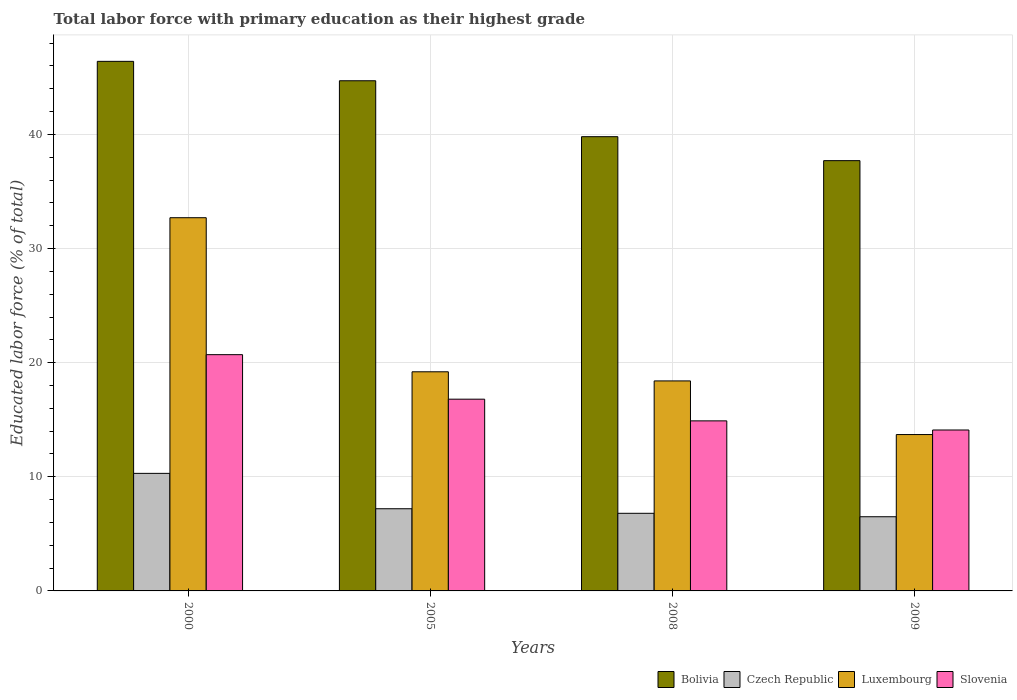How many different coloured bars are there?
Your response must be concise. 4. How many groups of bars are there?
Offer a very short reply. 4. Are the number of bars on each tick of the X-axis equal?
Your answer should be very brief. Yes. How many bars are there on the 3rd tick from the right?
Your answer should be very brief. 4. In how many cases, is the number of bars for a given year not equal to the number of legend labels?
Your answer should be compact. 0. What is the percentage of total labor force with primary education in Luxembourg in 2008?
Your answer should be very brief. 18.4. Across all years, what is the maximum percentage of total labor force with primary education in Bolivia?
Give a very brief answer. 46.4. In which year was the percentage of total labor force with primary education in Bolivia minimum?
Your response must be concise. 2009. What is the total percentage of total labor force with primary education in Luxembourg in the graph?
Provide a succinct answer. 84. What is the difference between the percentage of total labor force with primary education in Slovenia in 2000 and the percentage of total labor force with primary education in Czech Republic in 2008?
Provide a succinct answer. 13.9. What is the average percentage of total labor force with primary education in Bolivia per year?
Offer a very short reply. 42.15. In the year 2000, what is the difference between the percentage of total labor force with primary education in Luxembourg and percentage of total labor force with primary education in Czech Republic?
Your answer should be very brief. 22.4. What is the ratio of the percentage of total labor force with primary education in Bolivia in 2005 to that in 2009?
Keep it short and to the point. 1.19. What is the difference between the highest and the second highest percentage of total labor force with primary education in Bolivia?
Offer a very short reply. 1.7. What is the difference between the highest and the lowest percentage of total labor force with primary education in Czech Republic?
Offer a very short reply. 3.8. In how many years, is the percentage of total labor force with primary education in Czech Republic greater than the average percentage of total labor force with primary education in Czech Republic taken over all years?
Offer a terse response. 1. Is it the case that in every year, the sum of the percentage of total labor force with primary education in Slovenia and percentage of total labor force with primary education in Bolivia is greater than the sum of percentage of total labor force with primary education in Czech Republic and percentage of total labor force with primary education in Luxembourg?
Provide a succinct answer. Yes. What does the 3rd bar from the left in 2008 represents?
Keep it short and to the point. Luxembourg. What does the 2nd bar from the right in 2008 represents?
Give a very brief answer. Luxembourg. Is it the case that in every year, the sum of the percentage of total labor force with primary education in Slovenia and percentage of total labor force with primary education in Czech Republic is greater than the percentage of total labor force with primary education in Luxembourg?
Give a very brief answer. No. Are all the bars in the graph horizontal?
Your response must be concise. No. How many years are there in the graph?
Your answer should be compact. 4. What is the difference between two consecutive major ticks on the Y-axis?
Keep it short and to the point. 10. Are the values on the major ticks of Y-axis written in scientific E-notation?
Offer a very short reply. No. What is the title of the graph?
Your answer should be very brief. Total labor force with primary education as their highest grade. What is the label or title of the Y-axis?
Keep it short and to the point. Educated labor force (% of total). What is the Educated labor force (% of total) of Bolivia in 2000?
Your answer should be compact. 46.4. What is the Educated labor force (% of total) of Czech Republic in 2000?
Make the answer very short. 10.3. What is the Educated labor force (% of total) of Luxembourg in 2000?
Your response must be concise. 32.7. What is the Educated labor force (% of total) in Slovenia in 2000?
Keep it short and to the point. 20.7. What is the Educated labor force (% of total) of Bolivia in 2005?
Your answer should be compact. 44.7. What is the Educated labor force (% of total) of Czech Republic in 2005?
Offer a very short reply. 7.2. What is the Educated labor force (% of total) of Luxembourg in 2005?
Your response must be concise. 19.2. What is the Educated labor force (% of total) in Slovenia in 2005?
Your answer should be compact. 16.8. What is the Educated labor force (% of total) of Bolivia in 2008?
Your answer should be very brief. 39.8. What is the Educated labor force (% of total) in Czech Republic in 2008?
Provide a short and direct response. 6.8. What is the Educated labor force (% of total) of Luxembourg in 2008?
Offer a terse response. 18.4. What is the Educated labor force (% of total) in Slovenia in 2008?
Offer a very short reply. 14.9. What is the Educated labor force (% of total) of Bolivia in 2009?
Ensure brevity in your answer.  37.7. What is the Educated labor force (% of total) of Czech Republic in 2009?
Give a very brief answer. 6.5. What is the Educated labor force (% of total) in Luxembourg in 2009?
Your answer should be compact. 13.7. What is the Educated labor force (% of total) of Slovenia in 2009?
Make the answer very short. 14.1. Across all years, what is the maximum Educated labor force (% of total) of Bolivia?
Provide a succinct answer. 46.4. Across all years, what is the maximum Educated labor force (% of total) in Czech Republic?
Keep it short and to the point. 10.3. Across all years, what is the maximum Educated labor force (% of total) of Luxembourg?
Your response must be concise. 32.7. Across all years, what is the maximum Educated labor force (% of total) of Slovenia?
Make the answer very short. 20.7. Across all years, what is the minimum Educated labor force (% of total) of Bolivia?
Give a very brief answer. 37.7. Across all years, what is the minimum Educated labor force (% of total) of Czech Republic?
Your answer should be very brief. 6.5. Across all years, what is the minimum Educated labor force (% of total) in Luxembourg?
Your answer should be compact. 13.7. Across all years, what is the minimum Educated labor force (% of total) of Slovenia?
Offer a terse response. 14.1. What is the total Educated labor force (% of total) in Bolivia in the graph?
Provide a short and direct response. 168.6. What is the total Educated labor force (% of total) of Czech Republic in the graph?
Provide a succinct answer. 30.8. What is the total Educated labor force (% of total) of Luxembourg in the graph?
Give a very brief answer. 84. What is the total Educated labor force (% of total) in Slovenia in the graph?
Offer a very short reply. 66.5. What is the difference between the Educated labor force (% of total) in Bolivia in 2000 and that in 2005?
Keep it short and to the point. 1.7. What is the difference between the Educated labor force (% of total) of Czech Republic in 2000 and that in 2005?
Offer a very short reply. 3.1. What is the difference between the Educated labor force (% of total) of Luxembourg in 2000 and that in 2005?
Offer a terse response. 13.5. What is the difference between the Educated labor force (% of total) in Slovenia in 2000 and that in 2005?
Provide a short and direct response. 3.9. What is the difference between the Educated labor force (% of total) of Bolivia in 2000 and that in 2008?
Keep it short and to the point. 6.6. What is the difference between the Educated labor force (% of total) in Czech Republic in 2000 and that in 2008?
Ensure brevity in your answer.  3.5. What is the difference between the Educated labor force (% of total) of Luxembourg in 2000 and that in 2008?
Provide a succinct answer. 14.3. What is the difference between the Educated labor force (% of total) of Slovenia in 2000 and that in 2008?
Provide a succinct answer. 5.8. What is the difference between the Educated labor force (% of total) in Bolivia in 2000 and that in 2009?
Your response must be concise. 8.7. What is the difference between the Educated labor force (% of total) of Czech Republic in 2000 and that in 2009?
Your response must be concise. 3.8. What is the difference between the Educated labor force (% of total) of Slovenia in 2000 and that in 2009?
Provide a succinct answer. 6.6. What is the difference between the Educated labor force (% of total) in Bolivia in 2005 and that in 2008?
Your answer should be very brief. 4.9. What is the difference between the Educated labor force (% of total) in Luxembourg in 2005 and that in 2008?
Ensure brevity in your answer.  0.8. What is the difference between the Educated labor force (% of total) of Slovenia in 2005 and that in 2008?
Give a very brief answer. 1.9. What is the difference between the Educated labor force (% of total) in Luxembourg in 2005 and that in 2009?
Offer a very short reply. 5.5. What is the difference between the Educated labor force (% of total) in Luxembourg in 2008 and that in 2009?
Make the answer very short. 4.7. What is the difference between the Educated labor force (% of total) in Slovenia in 2008 and that in 2009?
Give a very brief answer. 0.8. What is the difference between the Educated labor force (% of total) in Bolivia in 2000 and the Educated labor force (% of total) in Czech Republic in 2005?
Ensure brevity in your answer.  39.2. What is the difference between the Educated labor force (% of total) of Bolivia in 2000 and the Educated labor force (% of total) of Luxembourg in 2005?
Provide a succinct answer. 27.2. What is the difference between the Educated labor force (% of total) of Bolivia in 2000 and the Educated labor force (% of total) of Slovenia in 2005?
Offer a very short reply. 29.6. What is the difference between the Educated labor force (% of total) of Czech Republic in 2000 and the Educated labor force (% of total) of Slovenia in 2005?
Give a very brief answer. -6.5. What is the difference between the Educated labor force (% of total) in Luxembourg in 2000 and the Educated labor force (% of total) in Slovenia in 2005?
Keep it short and to the point. 15.9. What is the difference between the Educated labor force (% of total) of Bolivia in 2000 and the Educated labor force (% of total) of Czech Republic in 2008?
Offer a very short reply. 39.6. What is the difference between the Educated labor force (% of total) of Bolivia in 2000 and the Educated labor force (% of total) of Luxembourg in 2008?
Offer a terse response. 28. What is the difference between the Educated labor force (% of total) in Bolivia in 2000 and the Educated labor force (% of total) in Slovenia in 2008?
Offer a terse response. 31.5. What is the difference between the Educated labor force (% of total) of Bolivia in 2000 and the Educated labor force (% of total) of Czech Republic in 2009?
Your answer should be very brief. 39.9. What is the difference between the Educated labor force (% of total) in Bolivia in 2000 and the Educated labor force (% of total) in Luxembourg in 2009?
Give a very brief answer. 32.7. What is the difference between the Educated labor force (% of total) in Bolivia in 2000 and the Educated labor force (% of total) in Slovenia in 2009?
Keep it short and to the point. 32.3. What is the difference between the Educated labor force (% of total) of Czech Republic in 2000 and the Educated labor force (% of total) of Luxembourg in 2009?
Keep it short and to the point. -3.4. What is the difference between the Educated labor force (% of total) of Czech Republic in 2000 and the Educated labor force (% of total) of Slovenia in 2009?
Offer a very short reply. -3.8. What is the difference between the Educated labor force (% of total) in Luxembourg in 2000 and the Educated labor force (% of total) in Slovenia in 2009?
Provide a succinct answer. 18.6. What is the difference between the Educated labor force (% of total) of Bolivia in 2005 and the Educated labor force (% of total) of Czech Republic in 2008?
Your answer should be very brief. 37.9. What is the difference between the Educated labor force (% of total) in Bolivia in 2005 and the Educated labor force (% of total) in Luxembourg in 2008?
Your answer should be very brief. 26.3. What is the difference between the Educated labor force (% of total) in Bolivia in 2005 and the Educated labor force (% of total) in Slovenia in 2008?
Give a very brief answer. 29.8. What is the difference between the Educated labor force (% of total) in Luxembourg in 2005 and the Educated labor force (% of total) in Slovenia in 2008?
Keep it short and to the point. 4.3. What is the difference between the Educated labor force (% of total) in Bolivia in 2005 and the Educated labor force (% of total) in Czech Republic in 2009?
Your answer should be very brief. 38.2. What is the difference between the Educated labor force (% of total) of Bolivia in 2005 and the Educated labor force (% of total) of Slovenia in 2009?
Your response must be concise. 30.6. What is the difference between the Educated labor force (% of total) in Czech Republic in 2005 and the Educated labor force (% of total) in Luxembourg in 2009?
Your answer should be very brief. -6.5. What is the difference between the Educated labor force (% of total) in Luxembourg in 2005 and the Educated labor force (% of total) in Slovenia in 2009?
Provide a succinct answer. 5.1. What is the difference between the Educated labor force (% of total) of Bolivia in 2008 and the Educated labor force (% of total) of Czech Republic in 2009?
Your answer should be very brief. 33.3. What is the difference between the Educated labor force (% of total) of Bolivia in 2008 and the Educated labor force (% of total) of Luxembourg in 2009?
Offer a very short reply. 26.1. What is the difference between the Educated labor force (% of total) of Bolivia in 2008 and the Educated labor force (% of total) of Slovenia in 2009?
Make the answer very short. 25.7. What is the difference between the Educated labor force (% of total) in Czech Republic in 2008 and the Educated labor force (% of total) in Luxembourg in 2009?
Offer a very short reply. -6.9. What is the average Educated labor force (% of total) of Bolivia per year?
Provide a short and direct response. 42.15. What is the average Educated labor force (% of total) of Czech Republic per year?
Your answer should be very brief. 7.7. What is the average Educated labor force (% of total) of Slovenia per year?
Your response must be concise. 16.62. In the year 2000, what is the difference between the Educated labor force (% of total) of Bolivia and Educated labor force (% of total) of Czech Republic?
Provide a succinct answer. 36.1. In the year 2000, what is the difference between the Educated labor force (% of total) in Bolivia and Educated labor force (% of total) in Luxembourg?
Provide a short and direct response. 13.7. In the year 2000, what is the difference between the Educated labor force (% of total) of Bolivia and Educated labor force (% of total) of Slovenia?
Keep it short and to the point. 25.7. In the year 2000, what is the difference between the Educated labor force (% of total) in Czech Republic and Educated labor force (% of total) in Luxembourg?
Offer a terse response. -22.4. In the year 2005, what is the difference between the Educated labor force (% of total) of Bolivia and Educated labor force (% of total) of Czech Republic?
Offer a very short reply. 37.5. In the year 2005, what is the difference between the Educated labor force (% of total) of Bolivia and Educated labor force (% of total) of Luxembourg?
Your answer should be very brief. 25.5. In the year 2005, what is the difference between the Educated labor force (% of total) of Bolivia and Educated labor force (% of total) of Slovenia?
Provide a short and direct response. 27.9. In the year 2005, what is the difference between the Educated labor force (% of total) of Czech Republic and Educated labor force (% of total) of Luxembourg?
Your response must be concise. -12. In the year 2005, what is the difference between the Educated labor force (% of total) in Luxembourg and Educated labor force (% of total) in Slovenia?
Provide a short and direct response. 2.4. In the year 2008, what is the difference between the Educated labor force (% of total) in Bolivia and Educated labor force (% of total) in Luxembourg?
Provide a succinct answer. 21.4. In the year 2008, what is the difference between the Educated labor force (% of total) in Bolivia and Educated labor force (% of total) in Slovenia?
Give a very brief answer. 24.9. In the year 2008, what is the difference between the Educated labor force (% of total) in Czech Republic and Educated labor force (% of total) in Luxembourg?
Ensure brevity in your answer.  -11.6. In the year 2008, what is the difference between the Educated labor force (% of total) in Luxembourg and Educated labor force (% of total) in Slovenia?
Provide a succinct answer. 3.5. In the year 2009, what is the difference between the Educated labor force (% of total) of Bolivia and Educated labor force (% of total) of Czech Republic?
Ensure brevity in your answer.  31.2. In the year 2009, what is the difference between the Educated labor force (% of total) in Bolivia and Educated labor force (% of total) in Luxembourg?
Offer a very short reply. 24. In the year 2009, what is the difference between the Educated labor force (% of total) of Bolivia and Educated labor force (% of total) of Slovenia?
Your answer should be compact. 23.6. In the year 2009, what is the difference between the Educated labor force (% of total) of Czech Republic and Educated labor force (% of total) of Luxembourg?
Keep it short and to the point. -7.2. In the year 2009, what is the difference between the Educated labor force (% of total) in Luxembourg and Educated labor force (% of total) in Slovenia?
Offer a very short reply. -0.4. What is the ratio of the Educated labor force (% of total) in Bolivia in 2000 to that in 2005?
Your answer should be very brief. 1.04. What is the ratio of the Educated labor force (% of total) in Czech Republic in 2000 to that in 2005?
Provide a short and direct response. 1.43. What is the ratio of the Educated labor force (% of total) of Luxembourg in 2000 to that in 2005?
Give a very brief answer. 1.7. What is the ratio of the Educated labor force (% of total) in Slovenia in 2000 to that in 2005?
Provide a short and direct response. 1.23. What is the ratio of the Educated labor force (% of total) of Bolivia in 2000 to that in 2008?
Offer a very short reply. 1.17. What is the ratio of the Educated labor force (% of total) of Czech Republic in 2000 to that in 2008?
Offer a very short reply. 1.51. What is the ratio of the Educated labor force (% of total) in Luxembourg in 2000 to that in 2008?
Your answer should be very brief. 1.78. What is the ratio of the Educated labor force (% of total) of Slovenia in 2000 to that in 2008?
Ensure brevity in your answer.  1.39. What is the ratio of the Educated labor force (% of total) in Bolivia in 2000 to that in 2009?
Offer a terse response. 1.23. What is the ratio of the Educated labor force (% of total) of Czech Republic in 2000 to that in 2009?
Provide a short and direct response. 1.58. What is the ratio of the Educated labor force (% of total) in Luxembourg in 2000 to that in 2009?
Give a very brief answer. 2.39. What is the ratio of the Educated labor force (% of total) in Slovenia in 2000 to that in 2009?
Provide a succinct answer. 1.47. What is the ratio of the Educated labor force (% of total) in Bolivia in 2005 to that in 2008?
Ensure brevity in your answer.  1.12. What is the ratio of the Educated labor force (% of total) of Czech Republic in 2005 to that in 2008?
Offer a terse response. 1.06. What is the ratio of the Educated labor force (% of total) of Luxembourg in 2005 to that in 2008?
Offer a terse response. 1.04. What is the ratio of the Educated labor force (% of total) of Slovenia in 2005 to that in 2008?
Keep it short and to the point. 1.13. What is the ratio of the Educated labor force (% of total) of Bolivia in 2005 to that in 2009?
Give a very brief answer. 1.19. What is the ratio of the Educated labor force (% of total) of Czech Republic in 2005 to that in 2009?
Make the answer very short. 1.11. What is the ratio of the Educated labor force (% of total) of Luxembourg in 2005 to that in 2009?
Ensure brevity in your answer.  1.4. What is the ratio of the Educated labor force (% of total) of Slovenia in 2005 to that in 2009?
Ensure brevity in your answer.  1.19. What is the ratio of the Educated labor force (% of total) of Bolivia in 2008 to that in 2009?
Your answer should be compact. 1.06. What is the ratio of the Educated labor force (% of total) in Czech Republic in 2008 to that in 2009?
Your response must be concise. 1.05. What is the ratio of the Educated labor force (% of total) in Luxembourg in 2008 to that in 2009?
Provide a short and direct response. 1.34. What is the ratio of the Educated labor force (% of total) of Slovenia in 2008 to that in 2009?
Keep it short and to the point. 1.06. What is the difference between the highest and the second highest Educated labor force (% of total) of Bolivia?
Ensure brevity in your answer.  1.7. What is the difference between the highest and the second highest Educated labor force (% of total) of Czech Republic?
Provide a short and direct response. 3.1. What is the difference between the highest and the second highest Educated labor force (% of total) in Luxembourg?
Offer a terse response. 13.5. What is the difference between the highest and the lowest Educated labor force (% of total) in Bolivia?
Your response must be concise. 8.7. What is the difference between the highest and the lowest Educated labor force (% of total) of Luxembourg?
Your response must be concise. 19. 